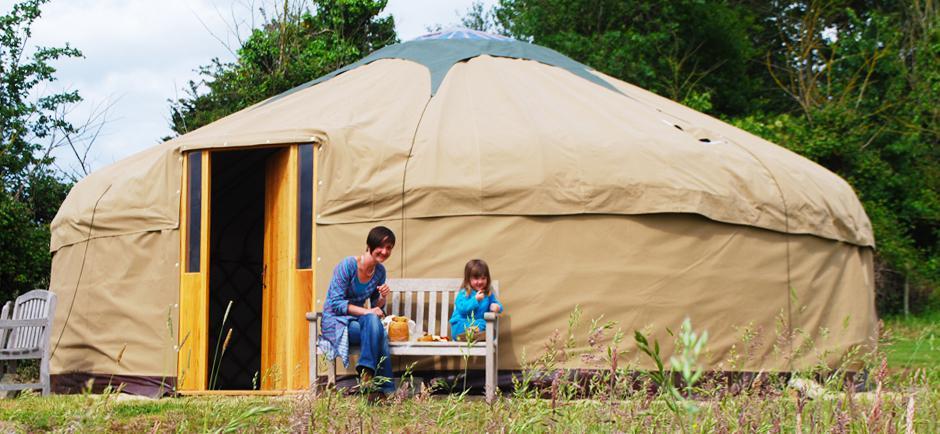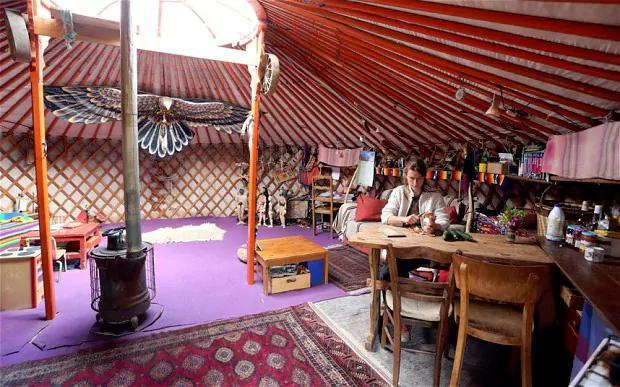The first image is the image on the left, the second image is the image on the right. Evaluate the accuracy of this statement regarding the images: "there is exactly one person in the image on the right.". Is it true? Answer yes or no. Yes. 